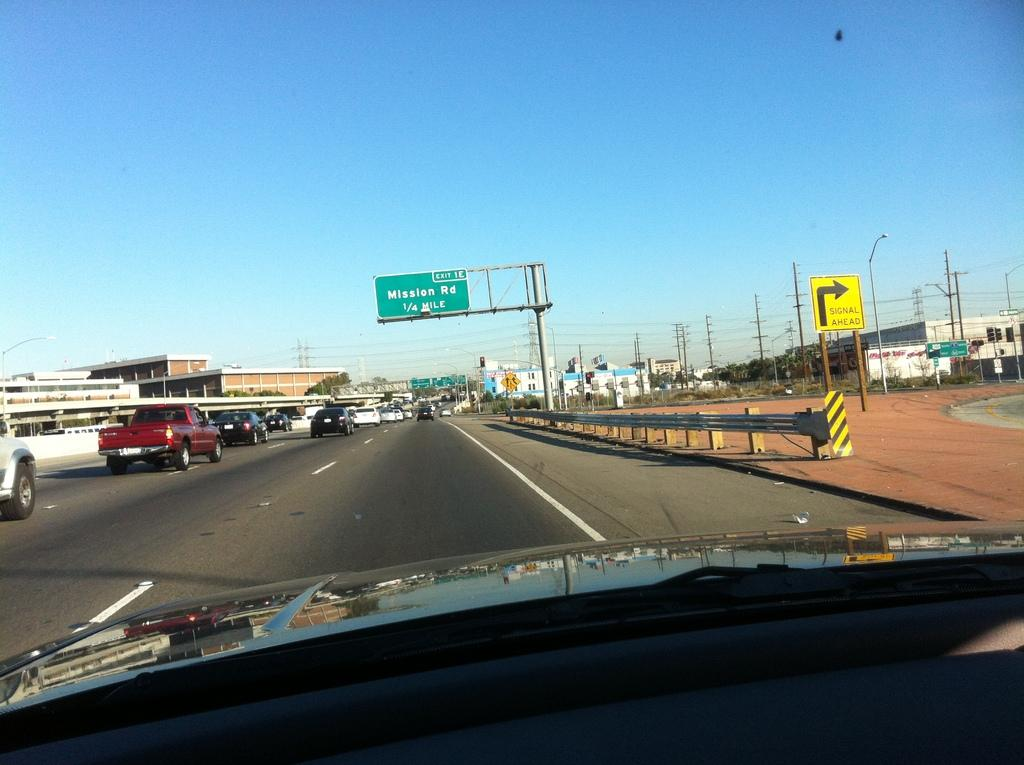What is the perspective of the image? The image is an outside view from a car. What can be seen on the road in the image? There are vehicles parked on the road. What type of structures are visible in the image? There are buildings visible in the image. How many children are playing in the image? There are no children present in the image. What type of adjustment is being made to the car in the image? There is no adjustment being made to the car in the image; it is simply an outside view from the car. 